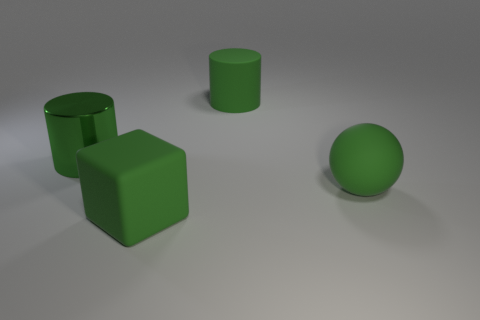Add 3 large yellow cubes. How many objects exist? 7 Subtract all balls. How many objects are left? 3 Subtract 1 blocks. How many blocks are left? 0 Subtract all large green shiny cylinders. Subtract all gray rubber cylinders. How many objects are left? 3 Add 2 cylinders. How many cylinders are left? 4 Add 3 big shiny objects. How many big shiny objects exist? 4 Subtract 0 blue cylinders. How many objects are left? 4 Subtract all red balls. Subtract all blue blocks. How many balls are left? 1 